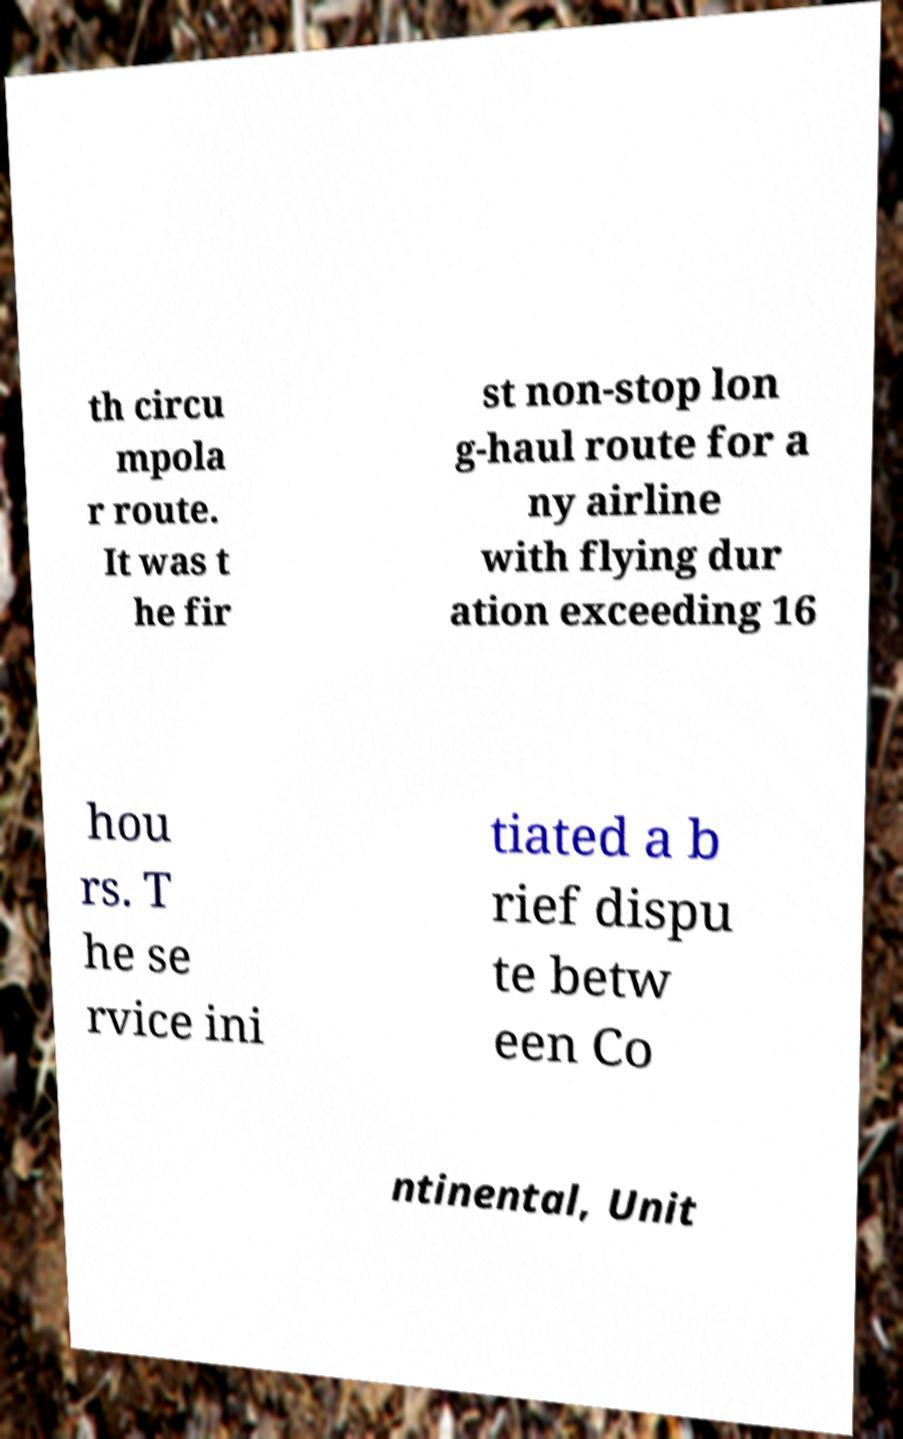Could you extract and type out the text from this image? th circu mpola r route. It was t he fir st non-stop lon g-haul route for a ny airline with flying dur ation exceeding 16 hou rs. T he se rvice ini tiated a b rief dispu te betw een Co ntinental, Unit 